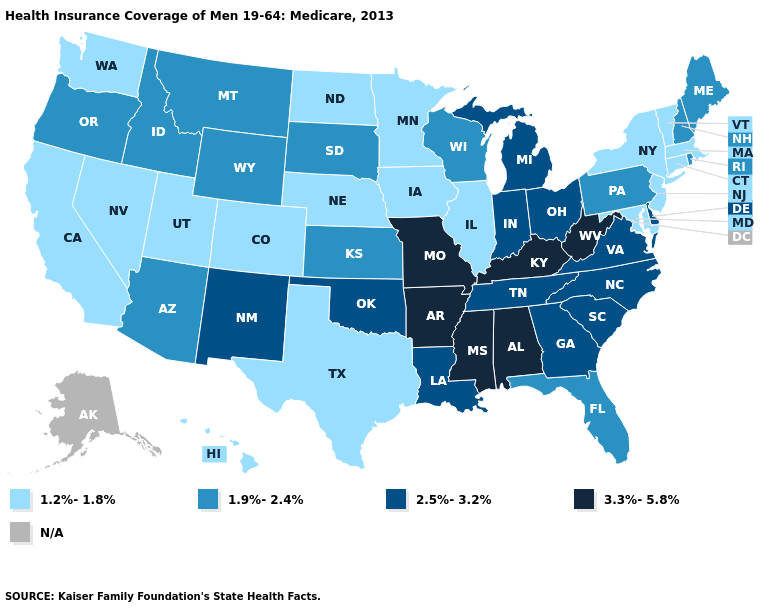What is the lowest value in states that border Wyoming?
Answer briefly. 1.2%-1.8%. Does Missouri have the highest value in the MidWest?
Write a very short answer. Yes. Name the states that have a value in the range 1.2%-1.8%?
Give a very brief answer. California, Colorado, Connecticut, Hawaii, Illinois, Iowa, Maryland, Massachusetts, Minnesota, Nebraska, Nevada, New Jersey, New York, North Dakota, Texas, Utah, Vermont, Washington. What is the highest value in states that border Massachusetts?
Short answer required. 1.9%-2.4%. Name the states that have a value in the range 1.2%-1.8%?
Give a very brief answer. California, Colorado, Connecticut, Hawaii, Illinois, Iowa, Maryland, Massachusetts, Minnesota, Nebraska, Nevada, New Jersey, New York, North Dakota, Texas, Utah, Vermont, Washington. Does the first symbol in the legend represent the smallest category?
Short answer required. Yes. What is the highest value in states that border Connecticut?
Answer briefly. 1.9%-2.4%. Name the states that have a value in the range 2.5%-3.2%?
Give a very brief answer. Delaware, Georgia, Indiana, Louisiana, Michigan, New Mexico, North Carolina, Ohio, Oklahoma, South Carolina, Tennessee, Virginia. What is the value of Virginia?
Be succinct. 2.5%-3.2%. What is the value of Tennessee?
Short answer required. 2.5%-3.2%. What is the value of Massachusetts?
Short answer required. 1.2%-1.8%. What is the highest value in states that border South Carolina?
Keep it brief. 2.5%-3.2%. 